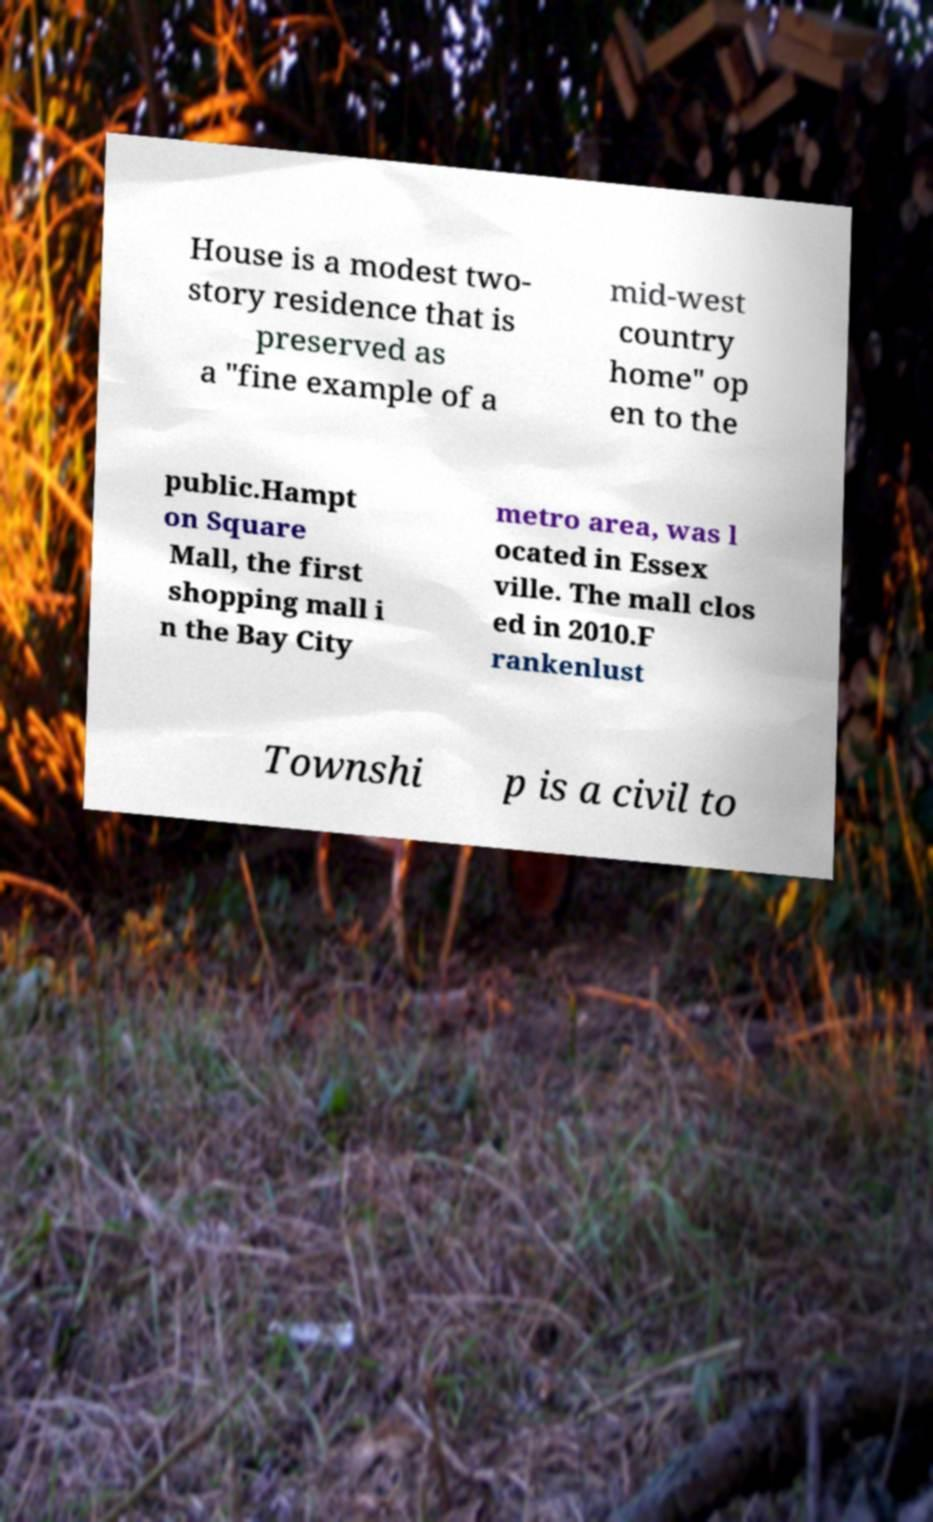Could you extract and type out the text from this image? House is a modest two- story residence that is preserved as a "fine example of a mid-west country home" op en to the public.Hampt on Square Mall, the first shopping mall i n the Bay City metro area, was l ocated in Essex ville. The mall clos ed in 2010.F rankenlust Townshi p is a civil to 